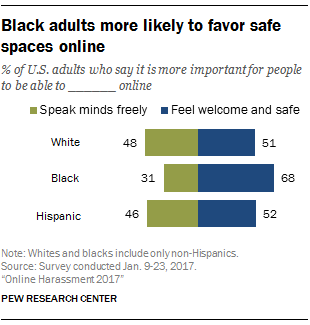Outline some significant characteristics in this image. The median of the green bars is 1.952777778 and the median of the blue bars is 1.952777778. After visualizing the bar graph, it can be stated that the blue bar dominates the green bar. 